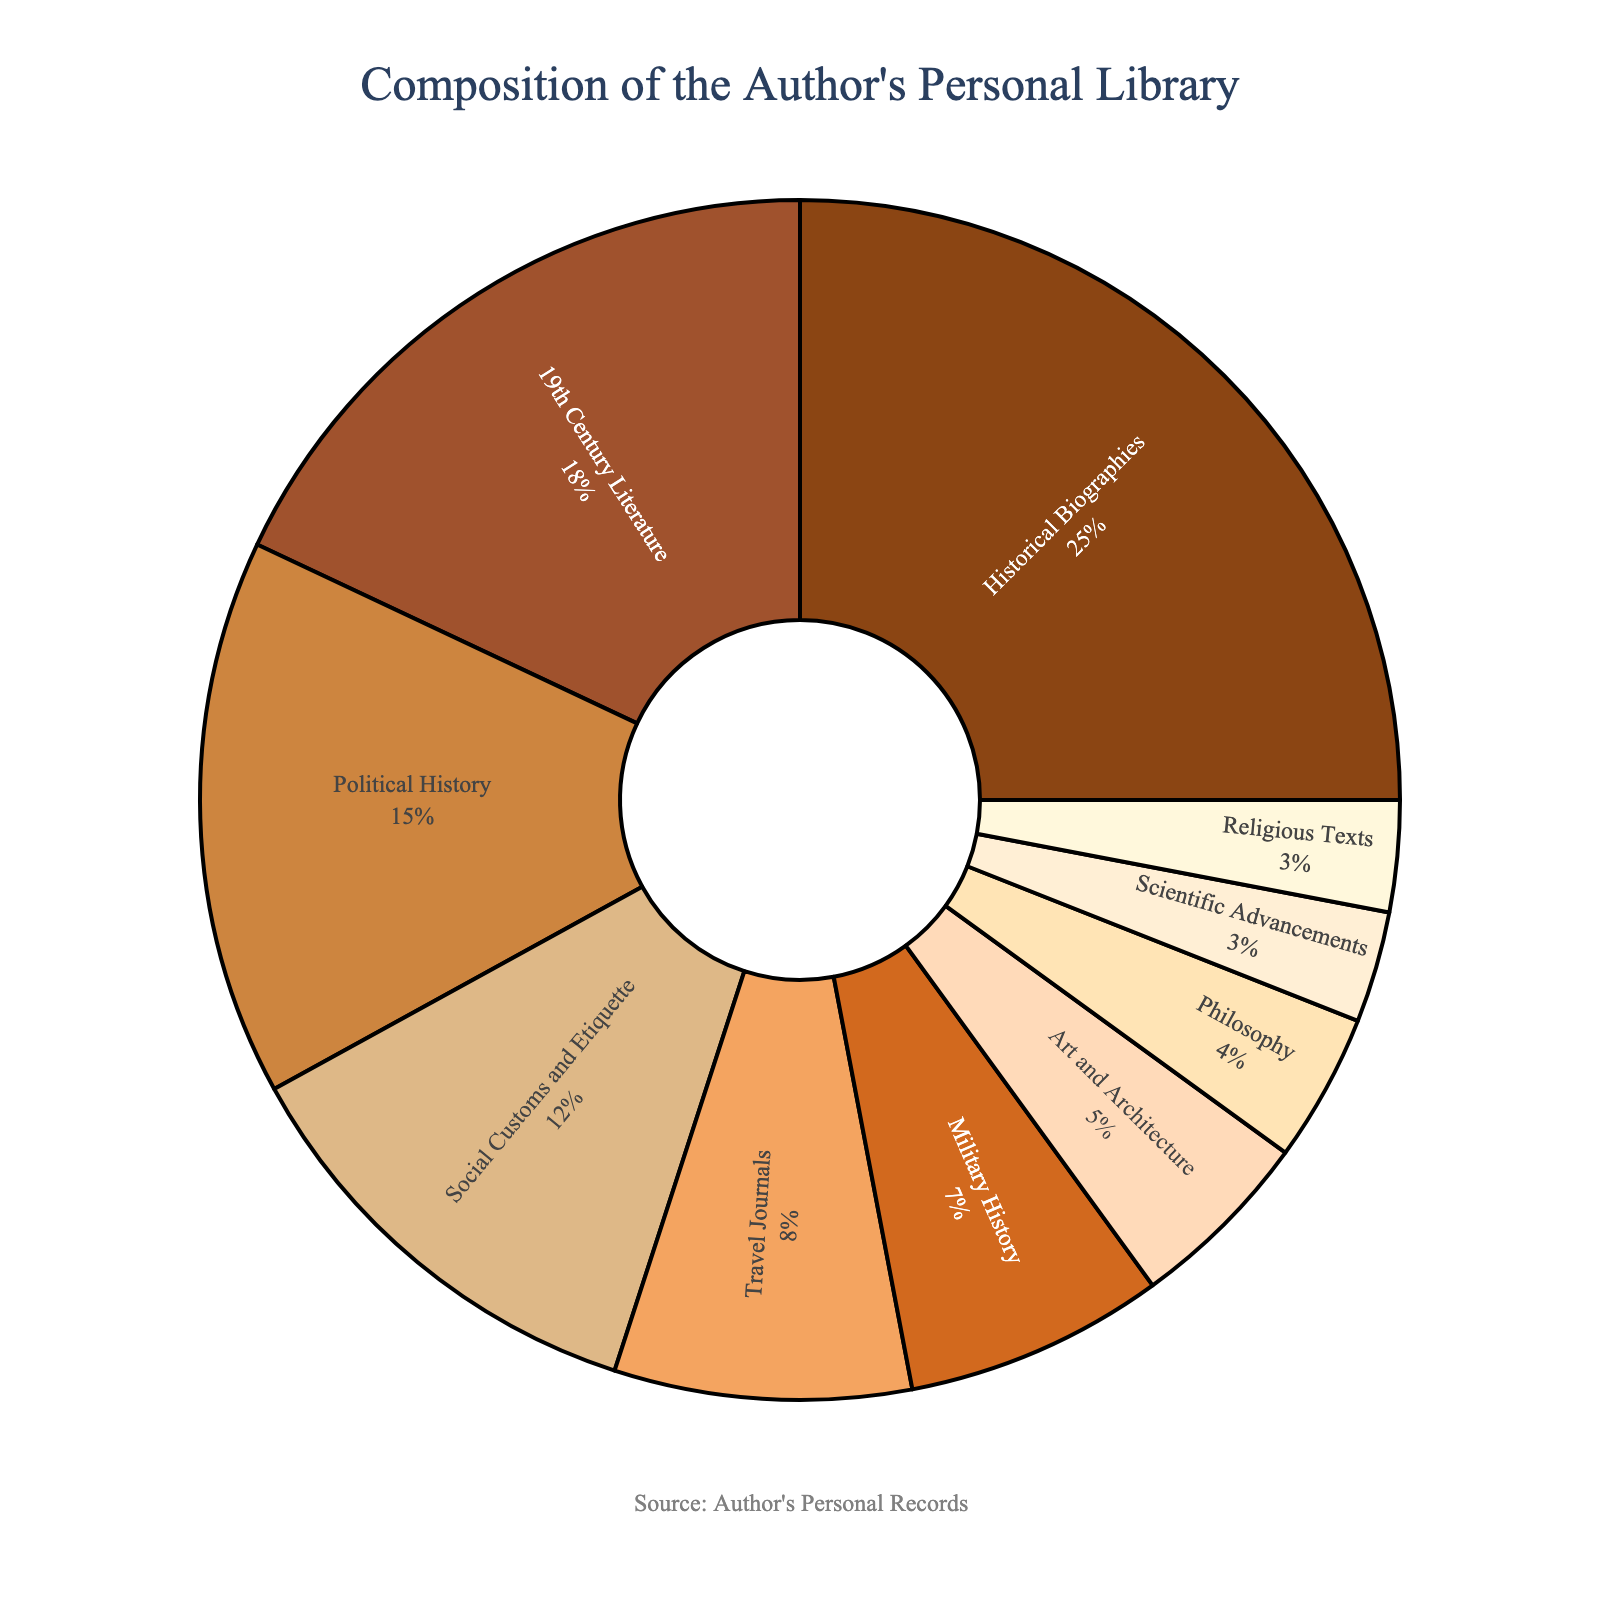What's the largest category in the author's library? The largest category can be found by looking at the slice with the highest percentage. "Historical Biographies" has the largest slice at 25%.
Answer: Historical Biographies Which category has the least representation? The category with the least representation can be determined by finding the smallest percentage. Both "Scientific Advancements" and "Religious Texts" have the smallest slices at 3%.
Answer: Scientific Advancements and Religious Texts How much more does 19th Century Literature constitute compared to Military History? "19th Century Literature" is 18% and "Military History" is 7%. The difference is 18% - 7%.
Answer: 11% If you sum the percentages of categories related to history, what total do you get? Categories related to history include "Historical Biographies" (25%), "Political History" (15%), and "Military History" (7%). Summing these: 25% + 15% + 7% = 47%.
Answer: 47% Which are the second and third most common categories in the author's library? The second and third largest categories can be found by finding the largest percentages after the top category. "19th Century Literature" is 18% and "Political History" is 15%.
Answer: 19th Century Literature and Political History Do the combined categories of Art and Architecture, and Philosophy exceed the percentage of Social Customs and Etiquette? "Art and Architecture" is 5% and "Philosophy" is 4%, their combined percentage is 5% + 4% = 9%. "Social Customs and Etiquette" is 12%, so 9% is less than 12%.
Answer: No What is the approximate percentage representation of non-history categories in the library? First, sum the percentages of history-related categories: "Historical Biographies" (25%), "Political History" (15%), and "Military History" (7%), which totals 47%. The remaining categories sum to 53% (100% - 47%).
Answer: 53% True or False: "Religious Texts" comprise a greater percentage than "Scientific Advancements" in the author’s library? Both "Religious Texts" and "Scientific Advancements" are each at 3%.
Answer: False How does the percentage of Social Customs and Etiquette compare to Art and Architecture plus Scientific Advancements combined? "Social Customs and Etiquette" is 12%. "Art and Architecture" is 5% and "Scientific Advancements" is 3%, combined is 5% + 3% = 8%. Therefore, 12% is greater than 8%.
Answer: Greater Which categories together make up more than half of the library? "Historical Biographies" (25%), "19th Century Literature" (18%), and "Political History" (15%) together make up 25% + 18% + 15% = 58%, which is more than half of the library.
Answer: Historical Biographies, 19th Century Literature, and Political History 